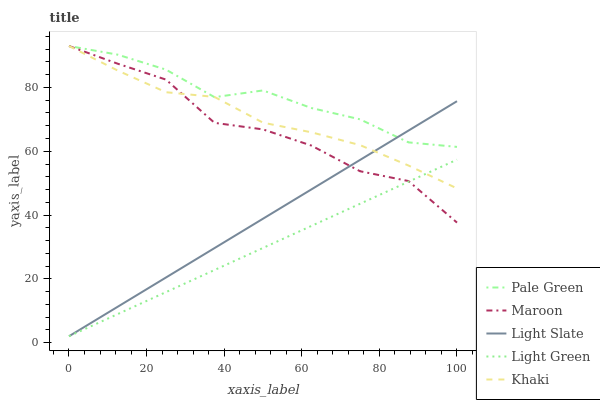Does Light Green have the minimum area under the curve?
Answer yes or no. Yes. Does Pale Green have the maximum area under the curve?
Answer yes or no. Yes. Does Khaki have the minimum area under the curve?
Answer yes or no. No. Does Khaki have the maximum area under the curve?
Answer yes or no. No. Is Light Green the smoothest?
Answer yes or no. Yes. Is Maroon the roughest?
Answer yes or no. Yes. Is Pale Green the smoothest?
Answer yes or no. No. Is Pale Green the roughest?
Answer yes or no. No. Does Khaki have the lowest value?
Answer yes or no. No. Does Maroon have the highest value?
Answer yes or no. Yes. Does Light Green have the highest value?
Answer yes or no. No. Is Light Green less than Pale Green?
Answer yes or no. Yes. Is Pale Green greater than Light Green?
Answer yes or no. Yes. Does Light Green intersect Pale Green?
Answer yes or no. No. 